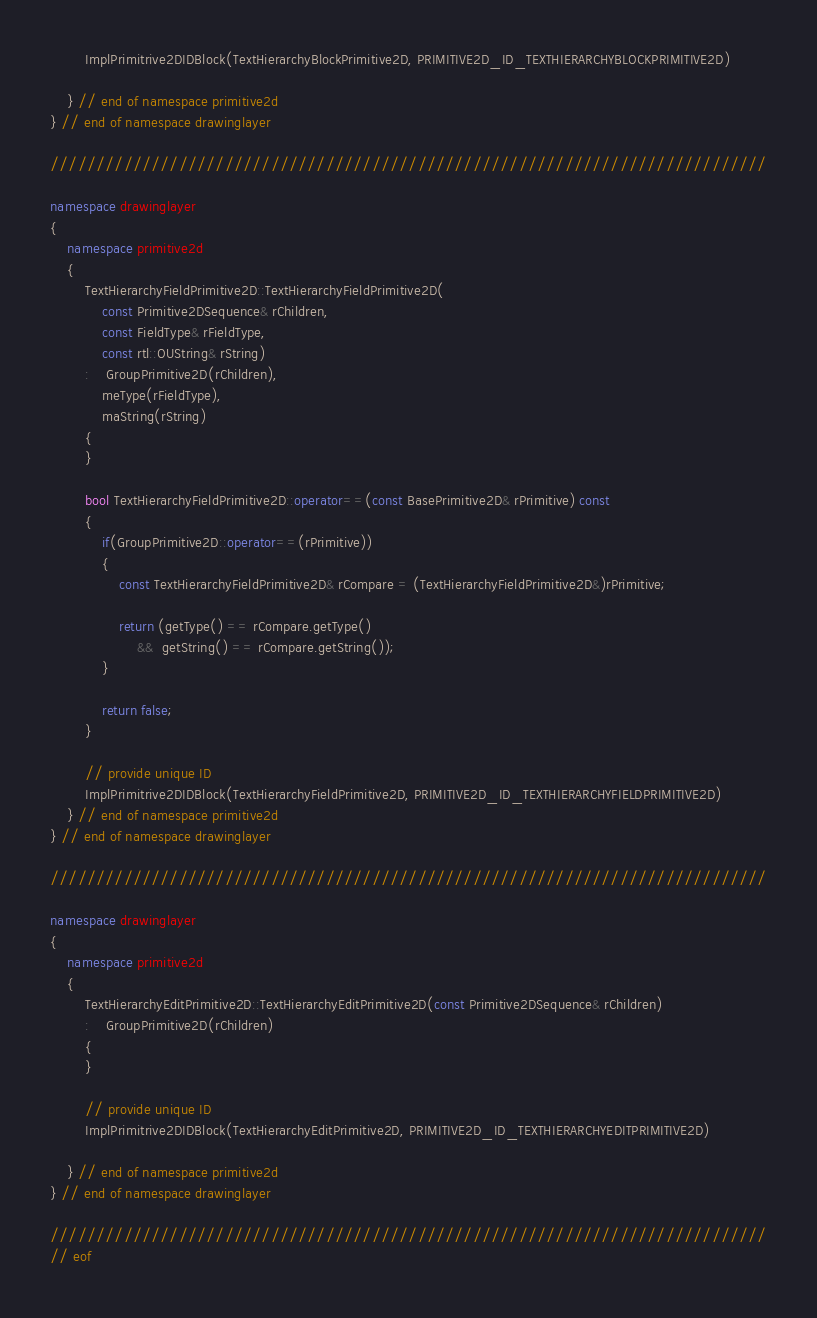Convert code to text. <code><loc_0><loc_0><loc_500><loc_500><_C++_>		ImplPrimitrive2DIDBlock(TextHierarchyBlockPrimitive2D, PRIMITIVE2D_ID_TEXTHIERARCHYBLOCKPRIMITIVE2D)

    } // end of namespace primitive2d
} // end of namespace drawinglayer

//////////////////////////////////////////////////////////////////////////////

namespace drawinglayer
{
	namespace primitive2d
	{
		TextHierarchyFieldPrimitive2D::TextHierarchyFieldPrimitive2D(
			const Primitive2DSequence& rChildren,
			const FieldType& rFieldType,
            const rtl::OUString& rString)
		:	GroupPrimitive2D(rChildren),
			meType(rFieldType),
			maString(rString)
		{
		}

		bool TextHierarchyFieldPrimitive2D::operator==(const BasePrimitive2D& rPrimitive) const
		{
			if(GroupPrimitive2D::operator==(rPrimitive))
			{
				const TextHierarchyFieldPrimitive2D& rCompare = (TextHierarchyFieldPrimitive2D&)rPrimitive;

				return (getType() == rCompare.getType()
                    &&  getString() == rCompare.getString());
			}

			return false;
		}

		// provide unique ID
		ImplPrimitrive2DIDBlock(TextHierarchyFieldPrimitive2D, PRIMITIVE2D_ID_TEXTHIERARCHYFIELDPRIMITIVE2D)
	} // end of namespace primitive2d
} // end of namespace drawinglayer

//////////////////////////////////////////////////////////////////////////////

namespace drawinglayer
{
	namespace primitive2d
	{
		TextHierarchyEditPrimitive2D::TextHierarchyEditPrimitive2D(const Primitive2DSequence& rChildren)
		:	GroupPrimitive2D(rChildren)
		{
		}

		// provide unique ID
		ImplPrimitrive2DIDBlock(TextHierarchyEditPrimitive2D, PRIMITIVE2D_ID_TEXTHIERARCHYEDITPRIMITIVE2D)

    } // end of namespace primitive2d
} // end of namespace drawinglayer

//////////////////////////////////////////////////////////////////////////////
// eof
</code> 